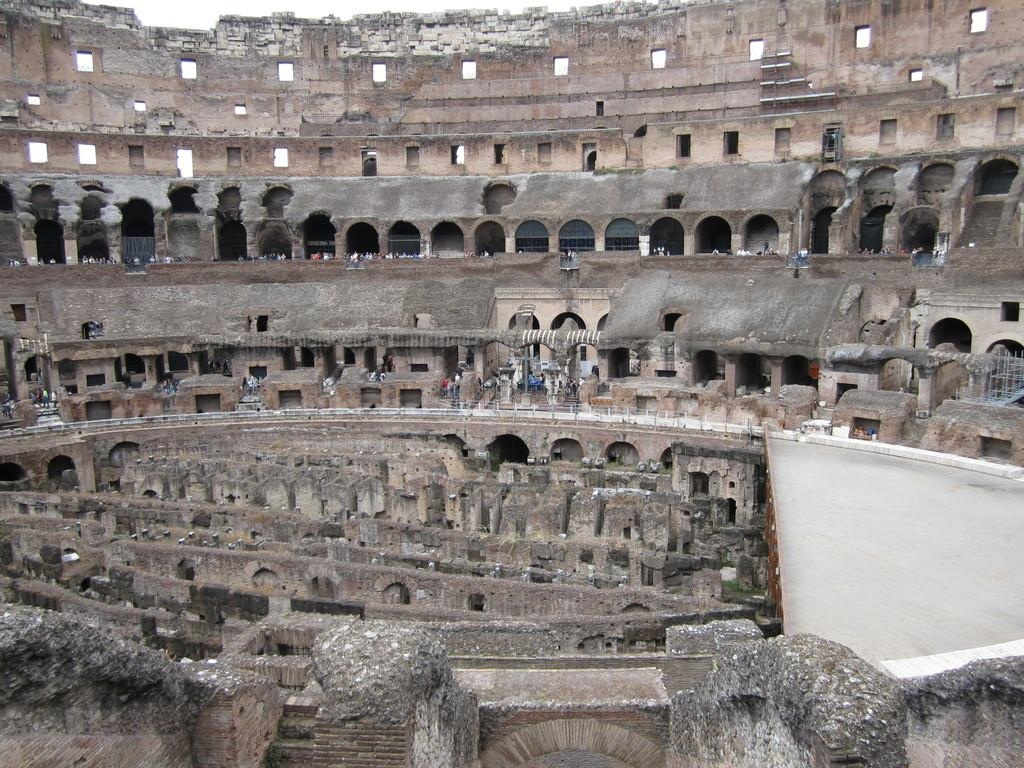What type of structure is visible in the image? There is a fort in the image. Are there any living beings present in the image? Yes, there are people in the image. Can you tell me when the goldfish was born in the image? There are no goldfish present in the image, so it is not possible to determine when a goldfish was born. 